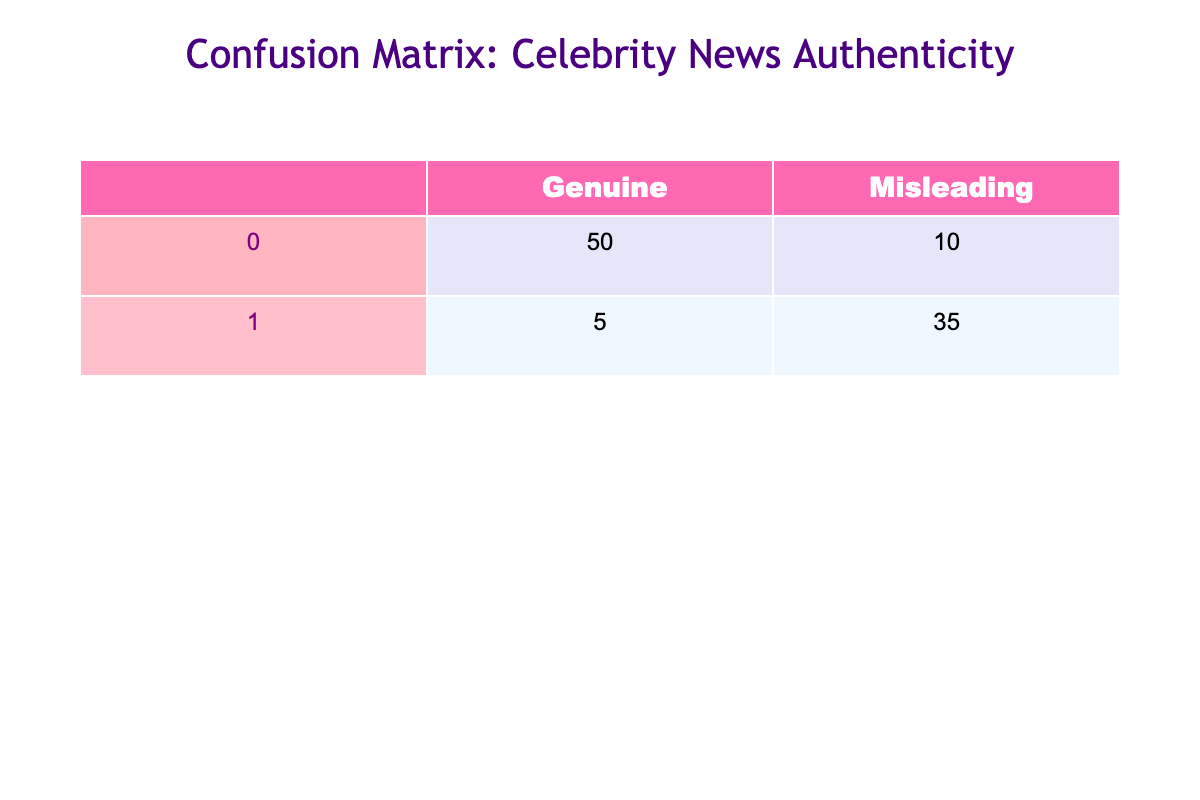What is the total number of Genuine news articles? To find the total number of Genuine news articles, we look at the "Genuine" column in the table. Adding the values in that column gives us 50 (True Positive) + 10 (False Negative) = 60.
Answer: 60 What is the total number of Misleading news articles? To find the total number of Misleading news articles, we look at the "Misleading" column in the table. Adding the values in that column gives us 5 (False Positive) + 35 (True Negative) = 40.
Answer: 40 How many articles were incorrectly identified as Genuine? The number of articles incorrectly identified as Genuine corresponds to False Negatives, which is given as 10 in the table.
Answer: 10 Is the number of Genuine articles greater than the number of Misleading articles? We compare the total values derived earlier: Genuine articles total 60 while Misleading articles total 40. Since 60 > 40, the statement is true.
Answer: Yes What is the accuracy of the classification? Accuracy is calculated as the sum of True Positives and True Negatives divided by the total number of articles. Here, (50 + 35) / (50 + 10 + 5 + 35) = 85 / 100 = 0.85 or 85%.
Answer: 85% How many more articles were identified as Misleading compared to Misleading articles known to be Genuine? To find this, we subtract the number of Genuine articles incorrectly classified as Misleading (False Negative, which is 10) from the total Misleading articles (40). Therefore, 40 - 10 = 30.
Answer: 30 If 70% of articles are actually Genuine, is the classification performance satisfactory? We check the proportion of correct classifications to determine performance. With 85 articles correctly classified and assuming 100 articles in total, 85% accuracy appears satisfactory compared to the 70% threshold. Therefore, we conclude that the classification performance is satisfactory.
Answer: Yes What percentage of Genuine articles were incorrectly classified as Misleading? To find this, we take the number of False Negatives (10) and divide by the total number of Genuine articles (60), resulting in (10 / 60) * 100 = 16.67%.
Answer: 16.67% What do the False Positive and False Negative numbers suggest about the reliability of the news sources? The False Positives (5) indicate few articles are mistakenly labeled as misleading, suggesting some reliability in identifying genuine news. However, high False Negatives (10) indicate a notable amount of genuine articles are misclassified, hinting at occasional inconsistency. Thus, while the sources are somewhat reliable, there is room for improvement.
Answer: Indicate some reliability but with room for improvement 